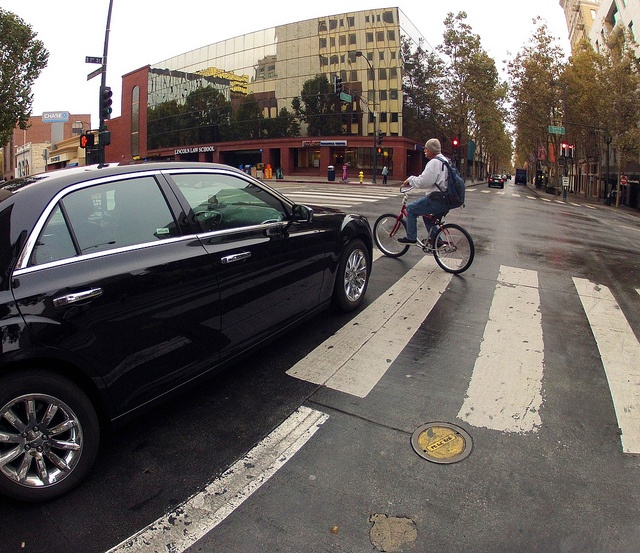Describe the objects in this image and their specific colors. I can see car in white, black, gray, and darkgray tones, bicycle in white, gray, black, and darkgray tones, people in white, black, darkgray, and gray tones, backpack in white, black, gray, and darkblue tones, and traffic light in white, black, gray, and maroon tones in this image. 